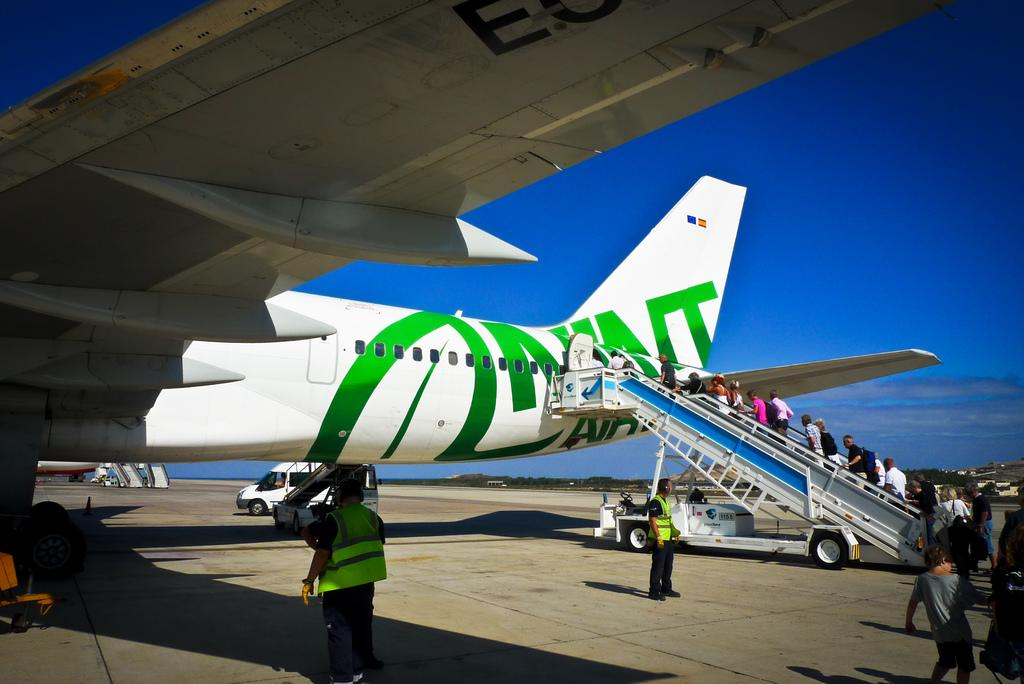Provide a one-sentence caption for the provided image. a white jet with green writing loading passengers on a staircase with the numbers 1155. 